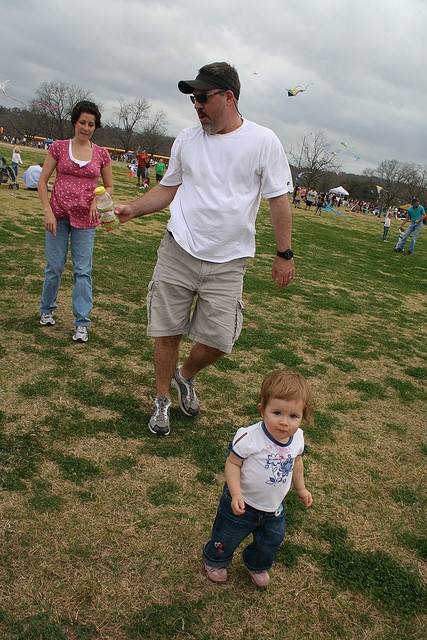Describe the objects in this image and their specific colors. I can see people in darkgray, lavender, and gray tones, people in darkgray, black, gray, and lightgray tones, people in darkgray, brown, gray, maroon, and black tones, people in darkgray, black, gray, tan, and maroon tones, and people in darkgray, teal, gray, and black tones in this image. 